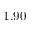Convert formula to latex. <formula><loc_0><loc_0><loc_500><loc_500>1 . 9 0</formula> 